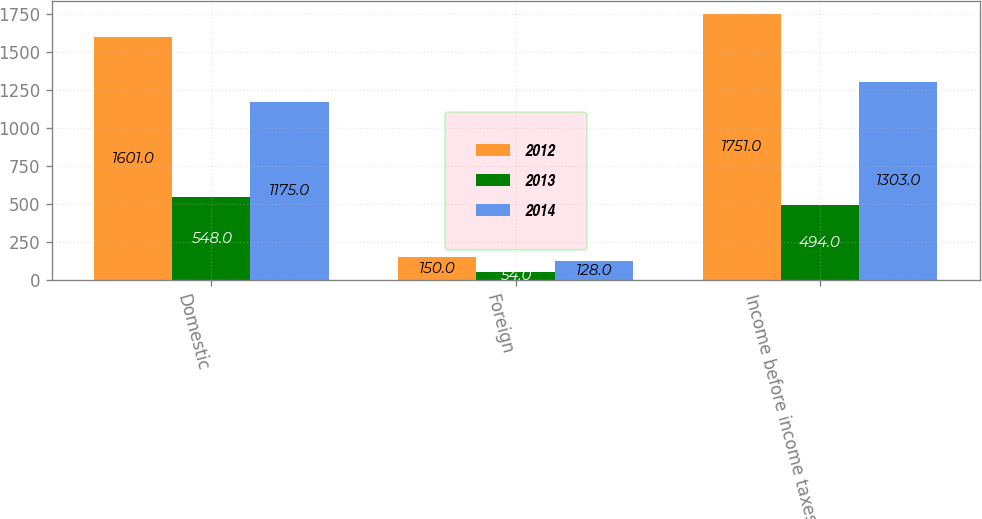<chart> <loc_0><loc_0><loc_500><loc_500><stacked_bar_chart><ecel><fcel>Domestic<fcel>Foreign<fcel>Income before income taxes<nl><fcel>2012<fcel>1601<fcel>150<fcel>1751<nl><fcel>2013<fcel>548<fcel>54<fcel>494<nl><fcel>2014<fcel>1175<fcel>128<fcel>1303<nl></chart> 